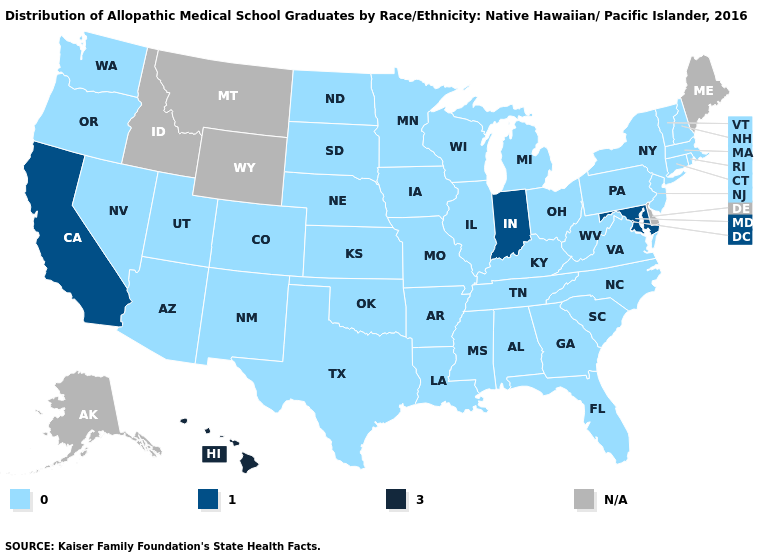What is the value of Oklahoma?
Write a very short answer. 0.0. Which states have the lowest value in the USA?
Concise answer only. Alabama, Arizona, Arkansas, Colorado, Connecticut, Florida, Georgia, Illinois, Iowa, Kansas, Kentucky, Louisiana, Massachusetts, Michigan, Minnesota, Mississippi, Missouri, Nebraska, Nevada, New Hampshire, New Jersey, New Mexico, New York, North Carolina, North Dakota, Ohio, Oklahoma, Oregon, Pennsylvania, Rhode Island, South Carolina, South Dakota, Tennessee, Texas, Utah, Vermont, Virginia, Washington, West Virginia, Wisconsin. What is the value of Maine?
Short answer required. N/A. Among the states that border Louisiana , which have the lowest value?
Keep it brief. Arkansas, Mississippi, Texas. What is the lowest value in states that border Arizona?
Quick response, please. 0.0. Which states hav the highest value in the South?
Concise answer only. Maryland. Name the states that have a value in the range 1.0?
Give a very brief answer. California, Indiana, Maryland. Does Hawaii have the highest value in the USA?
Keep it brief. Yes. What is the value of Oklahoma?
Quick response, please. 0.0. Is the legend a continuous bar?
Quick response, please. No. What is the lowest value in the USA?
Short answer required. 0.0. 